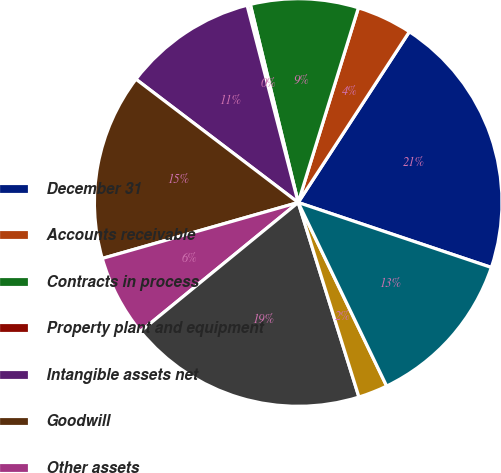<chart> <loc_0><loc_0><loc_500><loc_500><pie_chart><fcel>December 31<fcel>Accounts receivable<fcel>Contracts in process<fcel>Property plant and equipment<fcel>Intangible assets net<fcel>Goodwill<fcel>Other assets<fcel>Assets of discontinued<fcel>Accounts payable<fcel>Other liabilities<nl><fcel>20.98%<fcel>4.41%<fcel>8.55%<fcel>0.26%<fcel>10.62%<fcel>14.77%<fcel>6.48%<fcel>18.91%<fcel>2.33%<fcel>12.69%<nl></chart> 